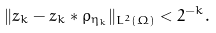<formula> <loc_0><loc_0><loc_500><loc_500>\| z _ { k } - z _ { k } * \rho _ { \eta _ { k } } \| _ { L ^ { 2 } ( \Omega ) } < 2 ^ { - k } .</formula> 